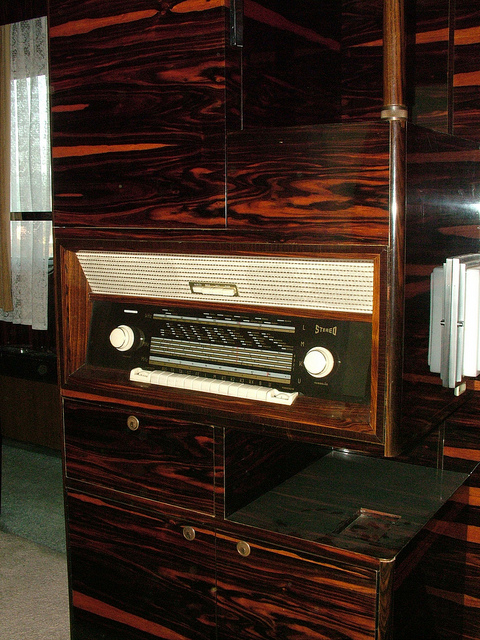Please transcribe the text in this image. STEREO 